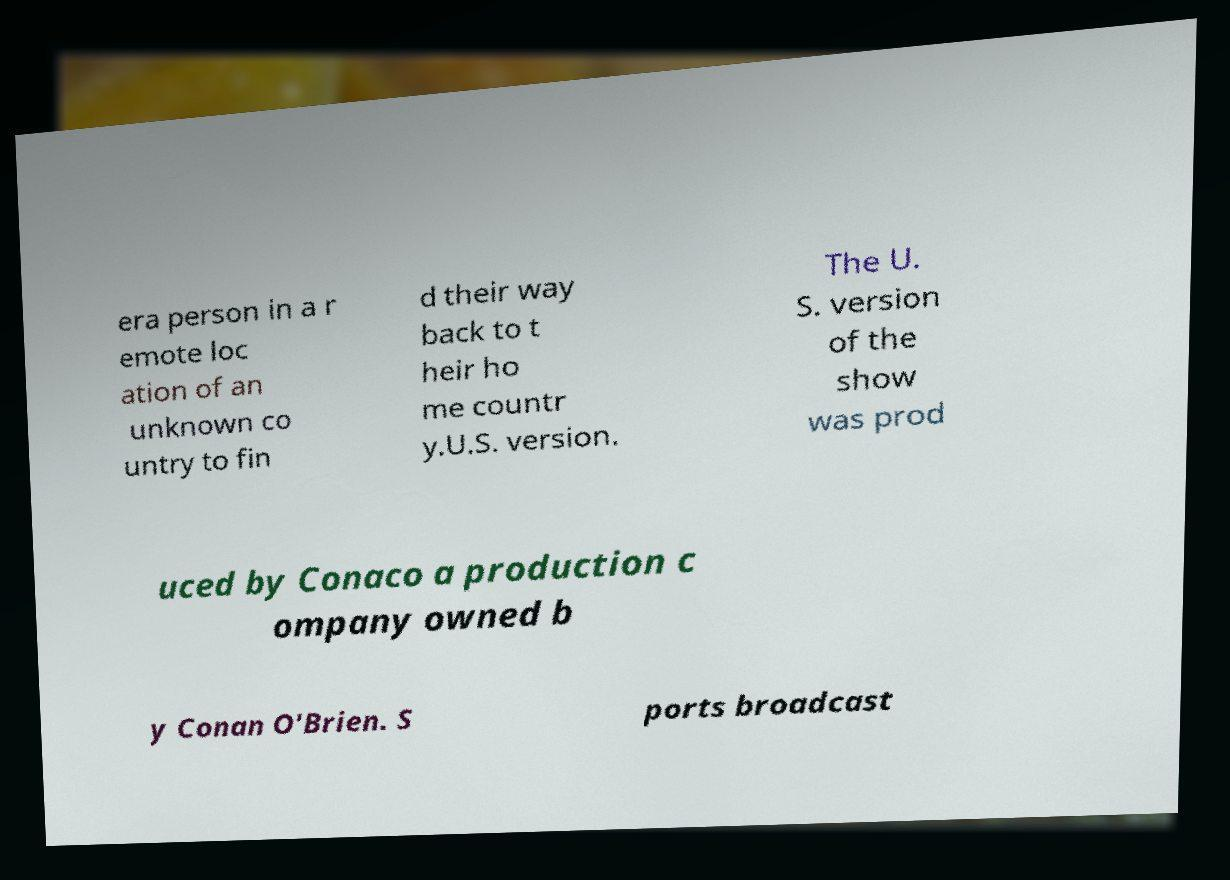Could you assist in decoding the text presented in this image and type it out clearly? era person in a r emote loc ation of an unknown co untry to fin d their way back to t heir ho me countr y.U.S. version. The U. S. version of the show was prod uced by Conaco a production c ompany owned b y Conan O'Brien. S ports broadcast 